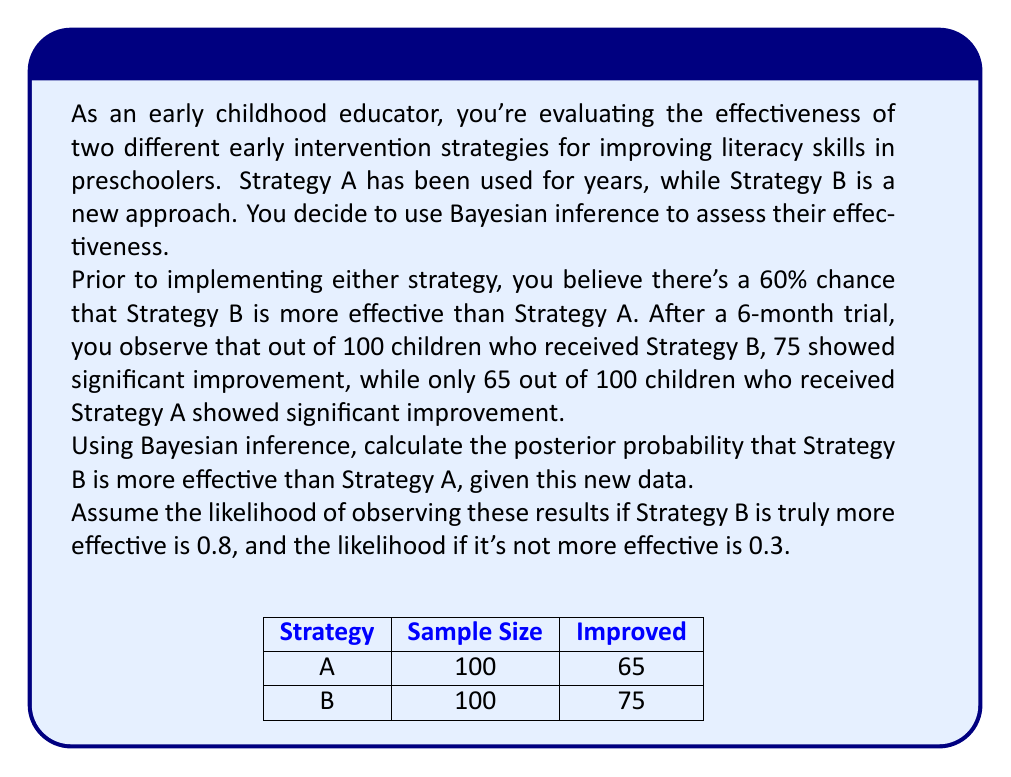Can you answer this question? Let's approach this step-by-step using Bayes' theorem:

1) Define our events:
   B: Strategy B is more effective than Strategy A
   D: Observed data (75/100 improved with B, 65/100 improved with A)

2) We need to calculate P(B|D) using Bayes' theorem:

   $$P(B|D) = \frac{P(D|B) \cdot P(B)}{P(D|B) \cdot P(B) + P(D|\text{not }B) \cdot P(\text{not }B)}$$

3) We're given:
   P(B) = 0.6 (prior probability)
   P(not B) = 1 - 0.6 = 0.4
   P(D|B) = 0.8 (likelihood if B is true)
   P(D|not B) = 0.3 (likelihood if B is not true)

4) Substitute these values into Bayes' theorem:

   $$P(B|D) = \frac{0.8 \cdot 0.6}{0.8 \cdot 0.6 + 0.3 \cdot 0.4}$$

5) Calculate:
   $$P(B|D) = \frac{0.48}{0.48 + 0.12} = \frac{0.48}{0.60} = 0.8$$

6) Convert to a percentage: 0.8 * 100 = 80%

Therefore, given the observed data, there is an 80% probability that Strategy B is more effective than Strategy A.
Answer: 80% 